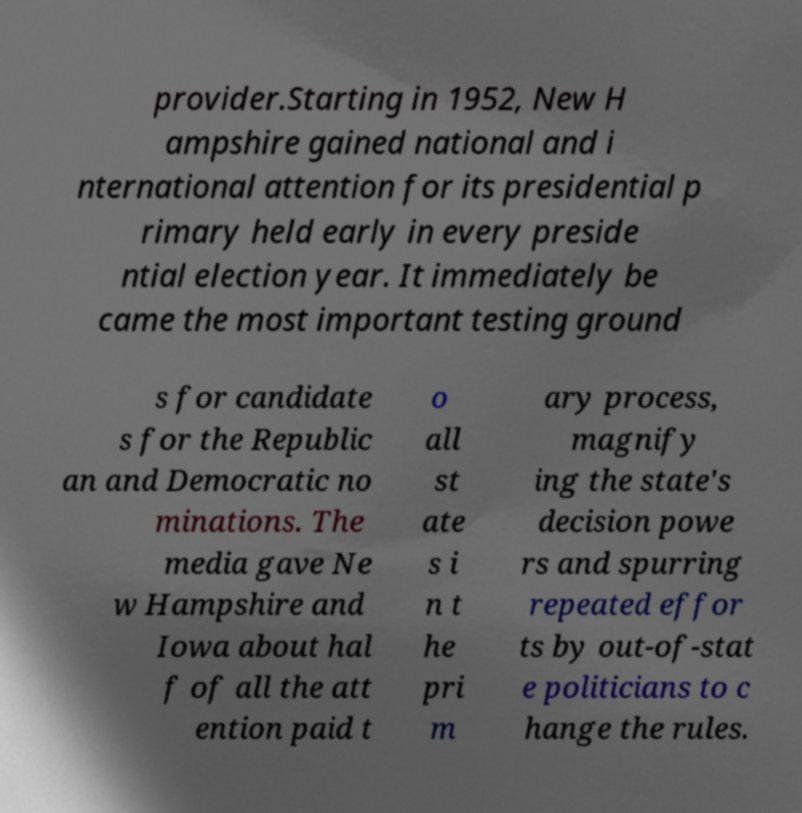Please identify and transcribe the text found in this image. provider.Starting in 1952, New H ampshire gained national and i nternational attention for its presidential p rimary held early in every preside ntial election year. It immediately be came the most important testing ground s for candidate s for the Republic an and Democratic no minations. The media gave Ne w Hampshire and Iowa about hal f of all the att ention paid t o all st ate s i n t he pri m ary process, magnify ing the state's decision powe rs and spurring repeated effor ts by out-of-stat e politicians to c hange the rules. 